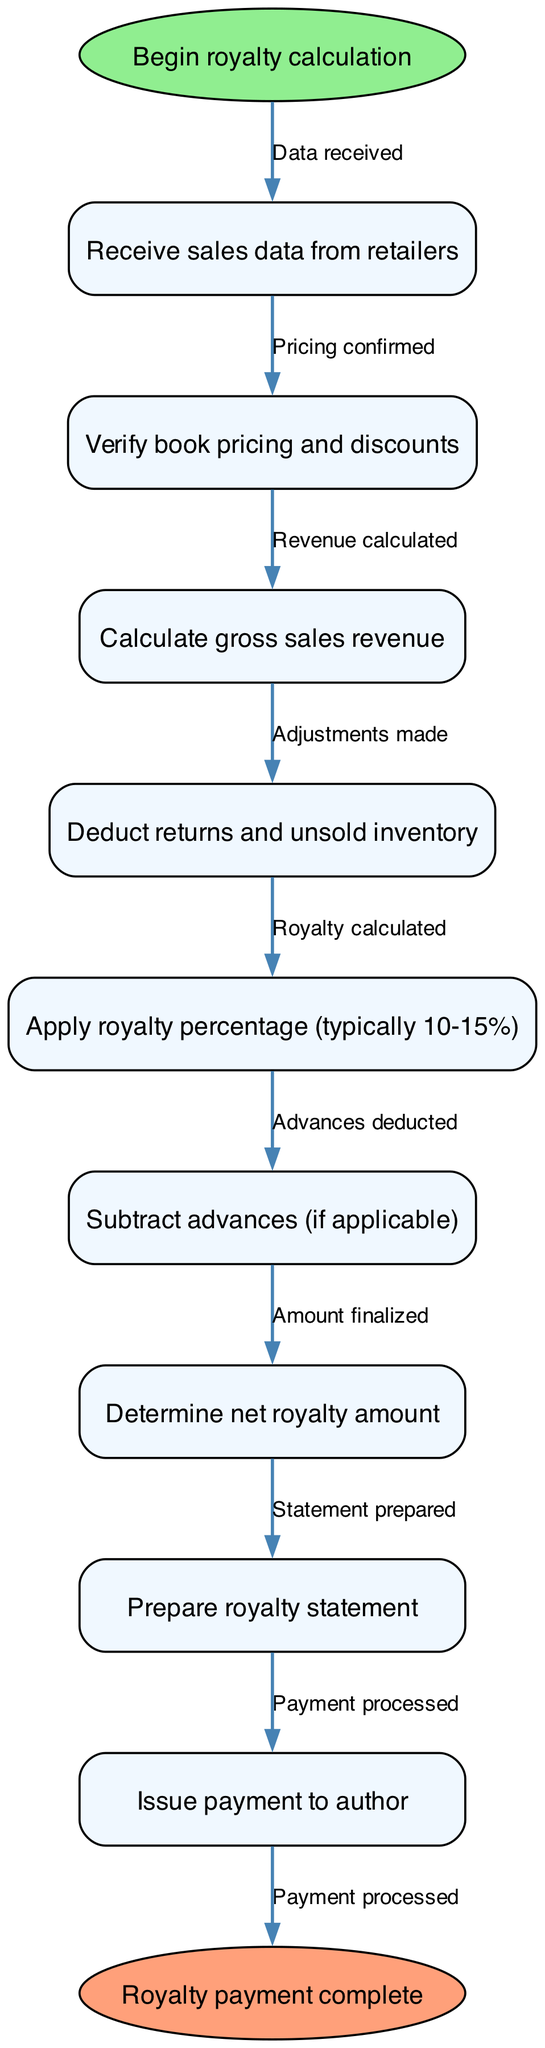What is the starting point of the flowchart? The starting point is specified under the "start" node, which states "Begin royalty calculation."
Answer: Begin royalty calculation How many nodes are in the diagram? The diagram contains a set of nodes that includes both the start and end nodes, alongside the process nodes. Counting all of them leads to a total of ten nodes.
Answer: 10 What is the final step in the royalty calculation? The final step is represented by the end node, stating "Royalty payment complete."
Answer: Royalty payment complete What is the first action in the process? The first action is described in the first node after the start, which indicates "Receive sales data from retailers."
Answer: Receive sales data from retailers How many edges are labeled "processed"? There is only one edge labeled "Payment processed," which connects the last process node to the end node of the flowchart.
Answer: 1 Which step involves confirming pricing? The step that involves confirming pricing is indicated by the node "Verify book pricing and discounts."
Answer: Verify book pricing and discounts What action follows the calculation of gross sales revenue? After calculating gross sales revenue, the next action is stated as "Deduct returns and unsold inventory."
Answer: Deduct returns and unsold inventory What takes place before issuing payment to the author? Before issuing payment, the process requires preparing a royalty statement, as indicated in the penultimate node.
Answer: Prepare royalty statement What percentage range is typically applied during the royalty calculation? The royalty percentage that is typically applied is indicated as a range of 10 to 15 percent in the relevant node.
Answer: 10-15% 